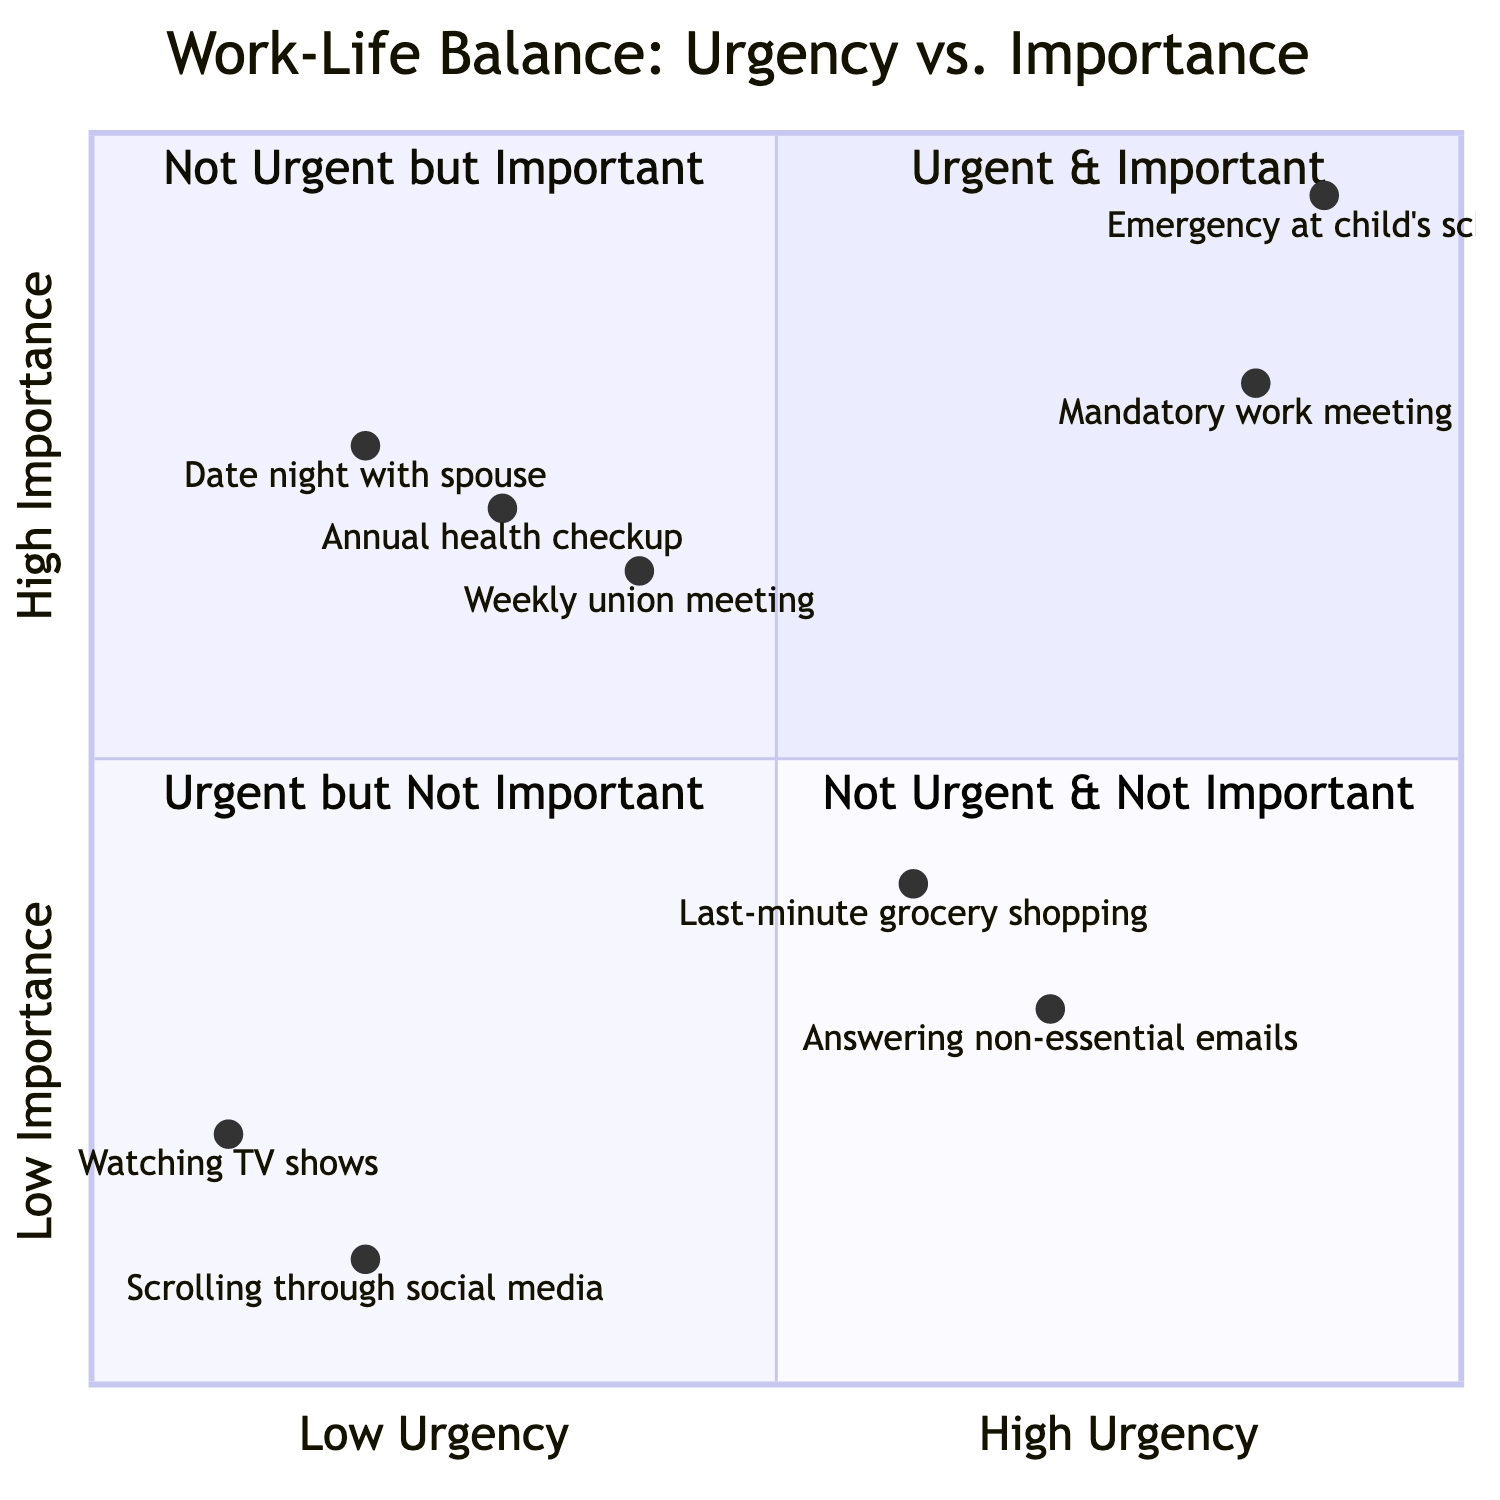What tasks are in the urgent and important quadrant? The urgent and important quadrant (Q1) includes tasks that require immediate attention and are critical, such as "Emergency at child’s school" and "Mandatory work meeting with upper management."
Answer: Emergency at child’s school, Mandatory work meeting How many tasks are in the not urgent but important quadrant? The not urgent but important quadrant (Q2) contains three tasks: "Annual health checkup," "Weekly union meeting," and "Date night with spouse." Therefore, the total number of tasks is 3.
Answer: 3 Which task is the most urgent but not important? To determine which task is the most urgent but not important (Q3), we look at the x-axis values. "Answering non-essential work emails" has a higher urgency score (0.7) compared to "Last-minute grocery shopping" (0.6), making it the most urgent but not important task.
Answer: Answering non-essential work emails What is the importance score of the last-minute grocery shopping task? The task "Last-minute grocery shopping" is located in the urgent but not important quadrant (Q3), and its importance score is 0.4.
Answer: 0.4 How many tasks are classified as not urgent and not important? The not urgent and not important quadrant (Q4) contains two tasks: "Scrolling through social media" and "Watching TV shows." Thus, there are 2 tasks in this category.
Answer: 2 Which task has the lowest importance score? Among all tasks, "Scrolling through social media" has the lowest importance score of 0.1, making it the task with the least importance.
Answer: Scrolling through social media What are the coordinates of the date night with spouse task? To find the coordinates of the "Date night with spouse" task in the not urgent but important quadrant (Q2), refer to the diagram, which shows its coordinates as [0.2, 0.75].
Answer: [0.2, 0.75] 